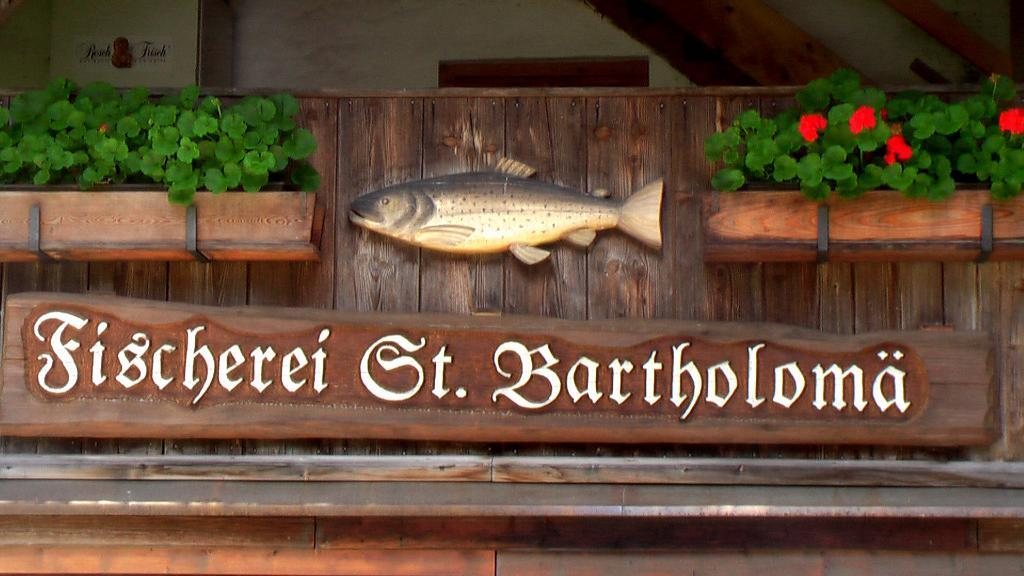What type of object is made of wood and present in the image? There is a wooden name plate and a wooden fish object in the image. What else can be seen in the image besides the wooden objects? Plants are visible in the image. How many cherries are on the wooden name plate in the image? There are no cherries present on the wooden name plate or in the image. 